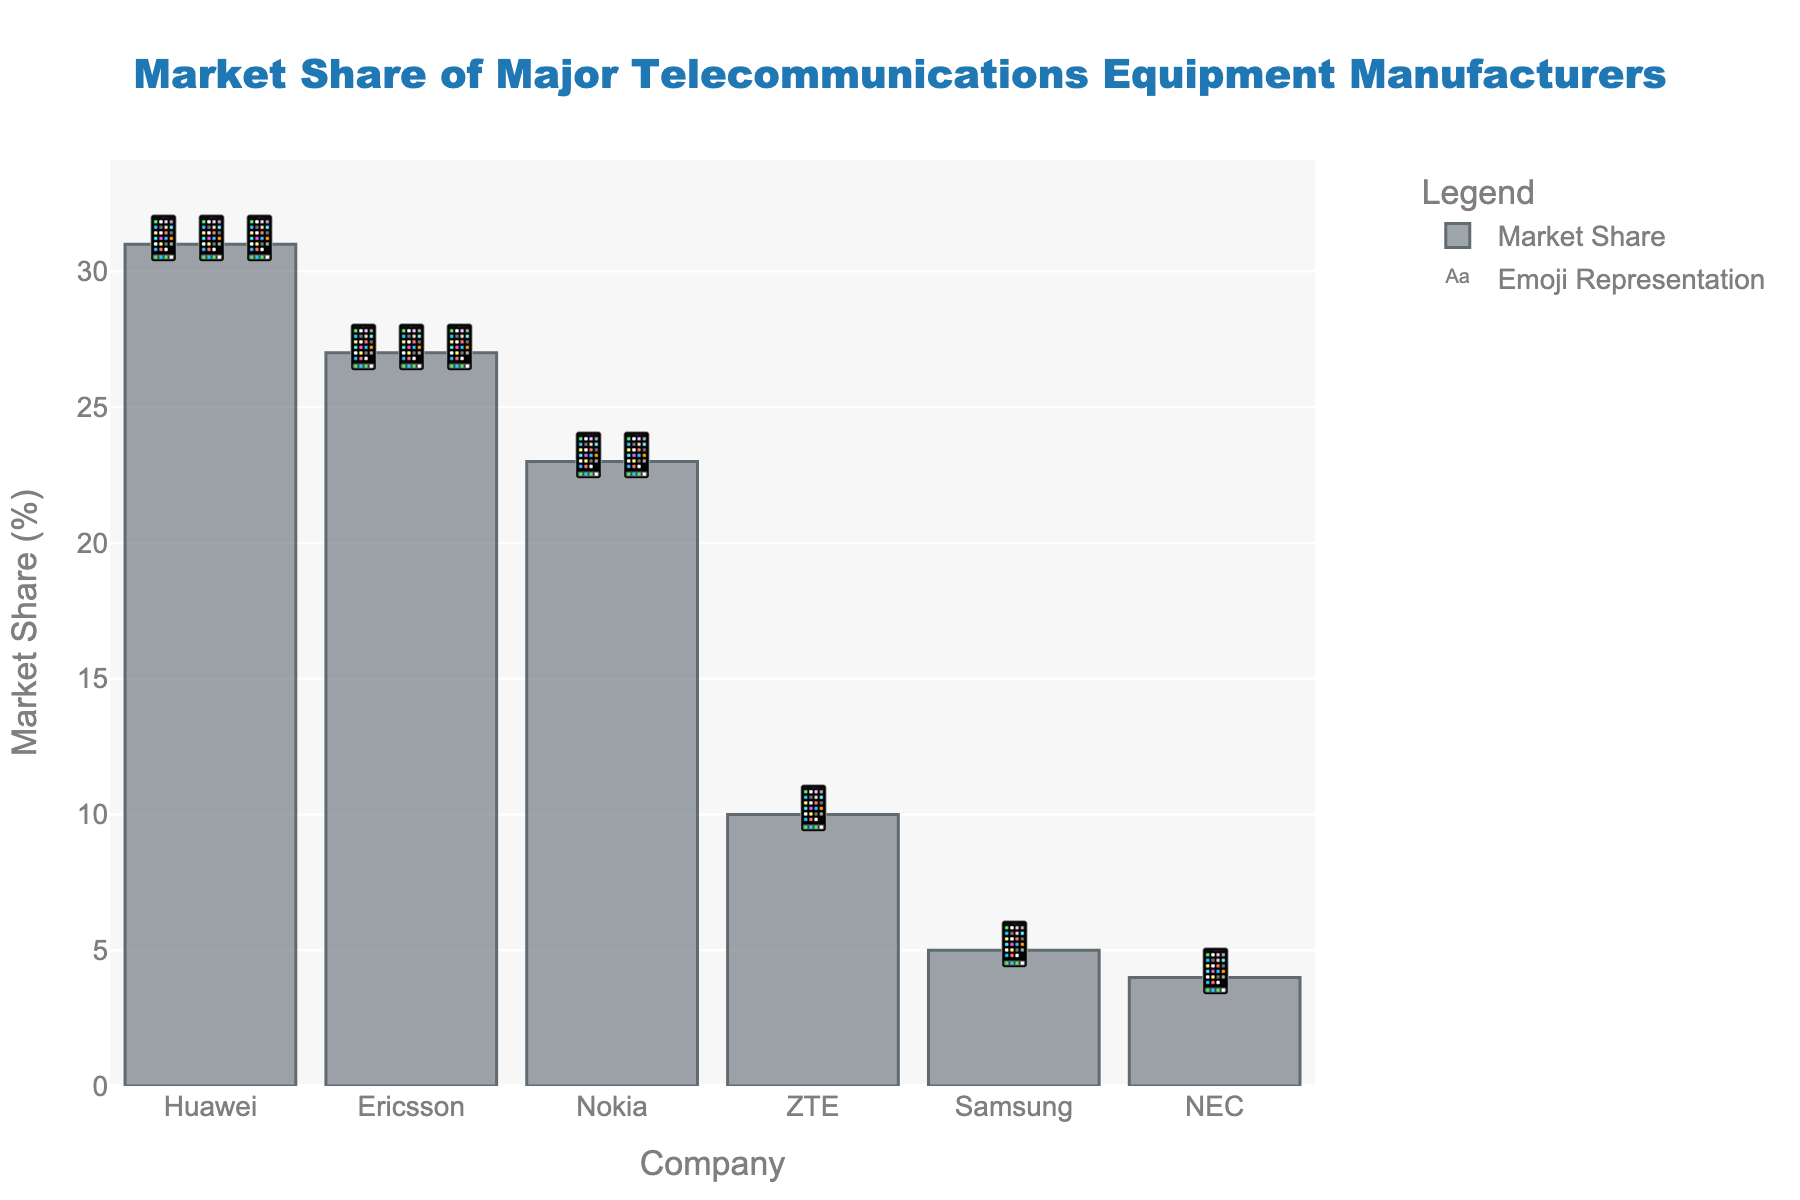who has the highest market share? The company with the highest market share is the one with the tallest bar and the most emojis.
Answer: Huawei What's the total market share of the top two companies? The market share for the top two companies, Huawei and Ericsson, is 31% and 27%, respectively. Adding them up gives 31 + 27 = 58%.
Answer: 58% How does Nokia's market share compare to Samsung's? Nokia has a market share of 23%, while Samsung has 5%. Comparing these, Nokia's market share is significantly higher.
Answer: Nokia has a higher market share than Samsung Which company has the smallest market share? The company with the smallest market share is the one with the shortest bar and fewest emojis.
Answer: NEC What is the combined market share of companies with less than 10% market share? Companies with less than 10% market share are Samsung (5%) and NEC (4%). Adding their shares gives 5 + 4 = 9%.
Answer: 9% Who are the top three manufacturers by market share? Looking at the bars and counting emojis, the top three manufacturers are Huawei, Ericsson, and Nokia.
Answer: Huawei, Ericsson, Nokia What’s the difference in market share between Huawei and ZTE? Huawei has a market share of 31% and ZTE has 10%. The difference is 31 - 10 = 21%.
Answer: 21% How many emojis are used to represent Ericsson's market share in the chart? For Ericsson's market share of 27%, three 📱 emojis are used.
Answer: 3 emojis What is the average market share of the companies shown in the chart? The market shares are 31, 27, 23, 10, 5, and 4. Adding them gives a total of 100. Dividing by 6 companies gives an average of 100 / 6 ≈ 16.67.
Answer: 16.67% How many companies have a market share greater than 20%? From the chart, the companies with more than 20% market share are Huawei (31%), Ericsson (27%), and Nokia (23%), totaling three companies.
Answer: 3 